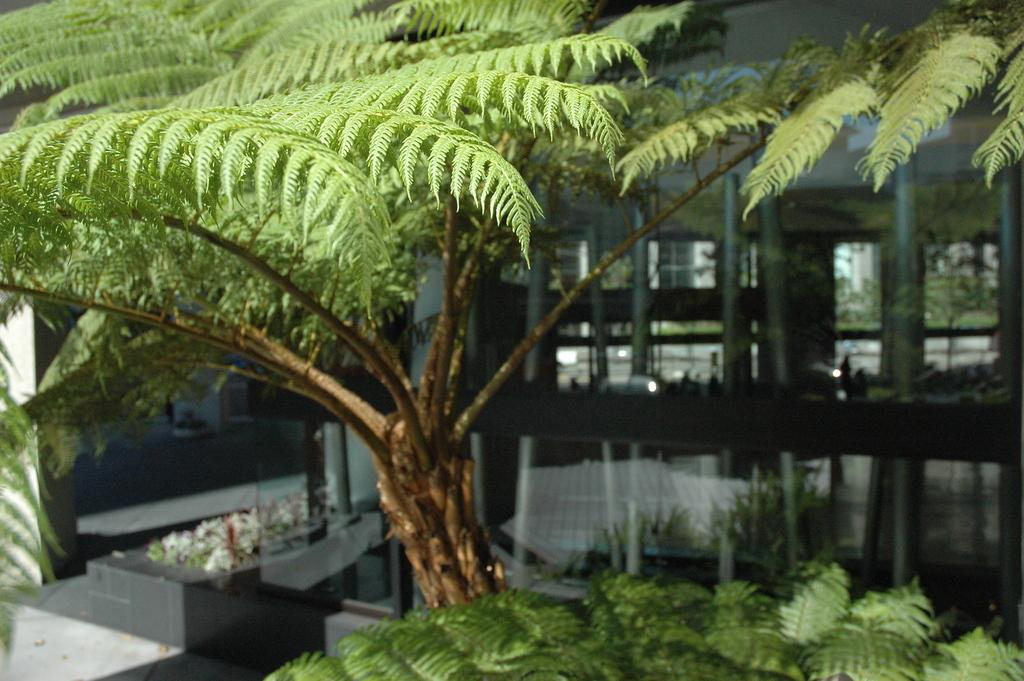What type of living organisms can be seen in the image? Plants can be seen in the image. What type of structure is present in the image? There is a building with pillars in the image. Where are the flowers located in the image? The flowers are on the left side of the image. What type of bat can be seen flying around the building in the image? There is no bat present in the image; it only features plants, a building with pillars, and flowers. 